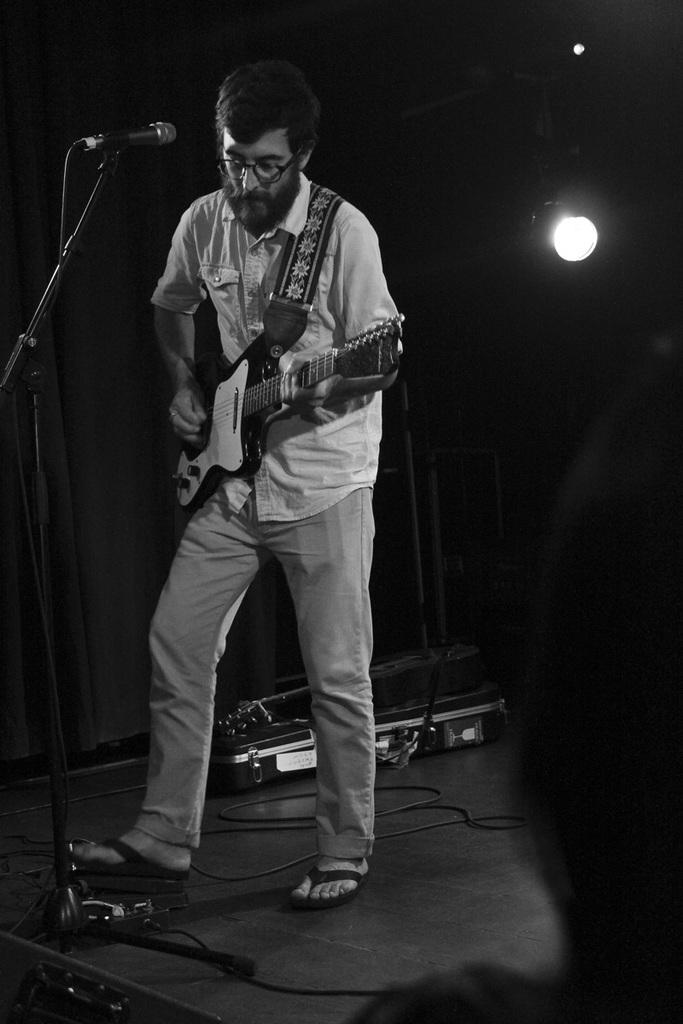What is the person in the image doing? The person is playing a guitar. What object is in front of the person? There is a microphone in front of the person. What type of flowers can be seen growing around the person in the image? There are no flowers visible in the image; the focus is on the person playing a guitar and the microphone in front of them. 